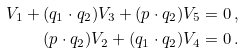<formula> <loc_0><loc_0><loc_500><loc_500>V _ { 1 } + ( q _ { 1 } \cdot q _ { 2 } ) V _ { 3 } + ( p \cdot q _ { 2 } ) V _ { 5 } = 0 \, , \\ ( p \cdot q _ { 2 } ) V _ { 2 } + ( q _ { 1 } \cdot q _ { 2 } ) V _ { 4 } = 0 \, .</formula> 